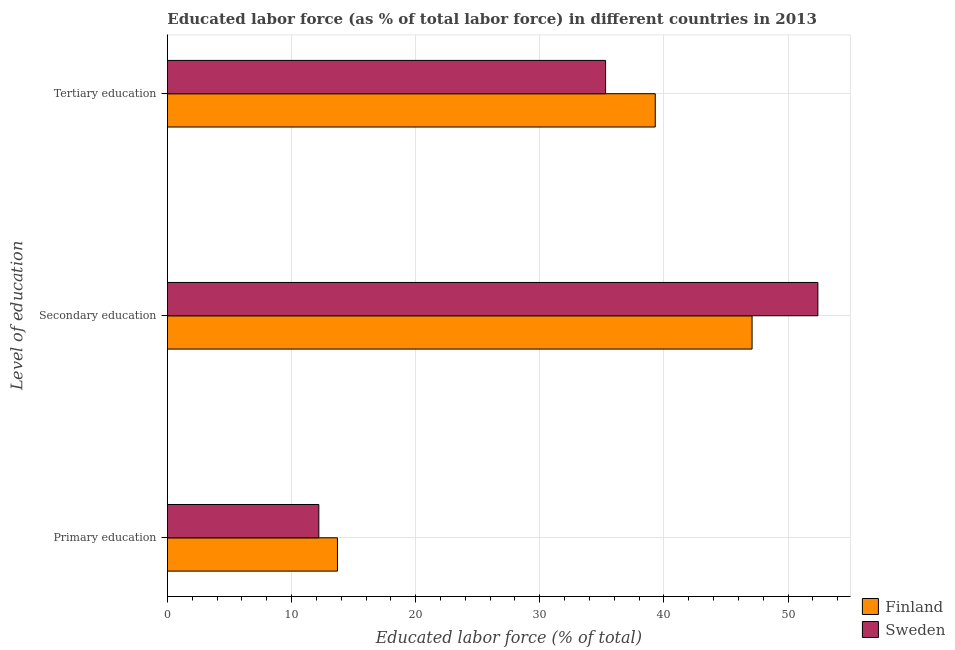How many bars are there on the 3rd tick from the top?
Provide a succinct answer. 2. What is the label of the 1st group of bars from the top?
Your answer should be compact. Tertiary education. What is the percentage of labor force who received primary education in Sweden?
Give a very brief answer. 12.2. Across all countries, what is the maximum percentage of labor force who received tertiary education?
Keep it short and to the point. 39.3. Across all countries, what is the minimum percentage of labor force who received tertiary education?
Your answer should be compact. 35.3. In which country was the percentage of labor force who received tertiary education maximum?
Offer a terse response. Finland. In which country was the percentage of labor force who received secondary education minimum?
Your response must be concise. Finland. What is the total percentage of labor force who received tertiary education in the graph?
Ensure brevity in your answer.  74.6. What is the difference between the percentage of labor force who received secondary education in Sweden and that in Finland?
Offer a terse response. 5.3. What is the difference between the percentage of labor force who received tertiary education in Sweden and the percentage of labor force who received secondary education in Finland?
Your answer should be compact. -11.8. What is the average percentage of labor force who received secondary education per country?
Make the answer very short. 49.75. What is the difference between the percentage of labor force who received tertiary education and percentage of labor force who received primary education in Sweden?
Your answer should be very brief. 23.1. In how many countries, is the percentage of labor force who received secondary education greater than 34 %?
Your answer should be very brief. 2. What is the ratio of the percentage of labor force who received primary education in Sweden to that in Finland?
Offer a very short reply. 0.89. What is the difference between the highest and the lowest percentage of labor force who received secondary education?
Provide a succinct answer. 5.3. What does the 2nd bar from the top in Primary education represents?
Give a very brief answer. Finland. How many bars are there?
Your answer should be very brief. 6. Are all the bars in the graph horizontal?
Make the answer very short. Yes. What is the difference between two consecutive major ticks on the X-axis?
Offer a very short reply. 10. Are the values on the major ticks of X-axis written in scientific E-notation?
Make the answer very short. No. Does the graph contain any zero values?
Offer a terse response. No. Does the graph contain grids?
Give a very brief answer. Yes. Where does the legend appear in the graph?
Your answer should be compact. Bottom right. How many legend labels are there?
Provide a short and direct response. 2. How are the legend labels stacked?
Ensure brevity in your answer.  Vertical. What is the title of the graph?
Your answer should be compact. Educated labor force (as % of total labor force) in different countries in 2013. Does "Trinidad and Tobago" appear as one of the legend labels in the graph?
Ensure brevity in your answer.  No. What is the label or title of the X-axis?
Provide a short and direct response. Educated labor force (% of total). What is the label or title of the Y-axis?
Provide a succinct answer. Level of education. What is the Educated labor force (% of total) in Finland in Primary education?
Your answer should be very brief. 13.7. What is the Educated labor force (% of total) in Sweden in Primary education?
Provide a short and direct response. 12.2. What is the Educated labor force (% of total) of Finland in Secondary education?
Offer a very short reply. 47.1. What is the Educated labor force (% of total) of Sweden in Secondary education?
Give a very brief answer. 52.4. What is the Educated labor force (% of total) of Finland in Tertiary education?
Give a very brief answer. 39.3. What is the Educated labor force (% of total) of Sweden in Tertiary education?
Your answer should be very brief. 35.3. Across all Level of education, what is the maximum Educated labor force (% of total) of Finland?
Offer a terse response. 47.1. Across all Level of education, what is the maximum Educated labor force (% of total) of Sweden?
Keep it short and to the point. 52.4. Across all Level of education, what is the minimum Educated labor force (% of total) in Finland?
Ensure brevity in your answer.  13.7. Across all Level of education, what is the minimum Educated labor force (% of total) of Sweden?
Offer a terse response. 12.2. What is the total Educated labor force (% of total) in Finland in the graph?
Make the answer very short. 100.1. What is the total Educated labor force (% of total) of Sweden in the graph?
Offer a very short reply. 99.9. What is the difference between the Educated labor force (% of total) in Finland in Primary education and that in Secondary education?
Provide a succinct answer. -33.4. What is the difference between the Educated labor force (% of total) in Sweden in Primary education and that in Secondary education?
Your response must be concise. -40.2. What is the difference between the Educated labor force (% of total) of Finland in Primary education and that in Tertiary education?
Offer a very short reply. -25.6. What is the difference between the Educated labor force (% of total) of Sweden in Primary education and that in Tertiary education?
Give a very brief answer. -23.1. What is the difference between the Educated labor force (% of total) of Finland in Secondary education and that in Tertiary education?
Ensure brevity in your answer.  7.8. What is the difference between the Educated labor force (% of total) of Finland in Primary education and the Educated labor force (% of total) of Sweden in Secondary education?
Your answer should be very brief. -38.7. What is the difference between the Educated labor force (% of total) of Finland in Primary education and the Educated labor force (% of total) of Sweden in Tertiary education?
Provide a short and direct response. -21.6. What is the difference between the Educated labor force (% of total) of Finland in Secondary education and the Educated labor force (% of total) of Sweden in Tertiary education?
Make the answer very short. 11.8. What is the average Educated labor force (% of total) of Finland per Level of education?
Keep it short and to the point. 33.37. What is the average Educated labor force (% of total) of Sweden per Level of education?
Your response must be concise. 33.3. What is the difference between the Educated labor force (% of total) in Finland and Educated labor force (% of total) in Sweden in Primary education?
Offer a terse response. 1.5. What is the difference between the Educated labor force (% of total) of Finland and Educated labor force (% of total) of Sweden in Tertiary education?
Provide a succinct answer. 4. What is the ratio of the Educated labor force (% of total) of Finland in Primary education to that in Secondary education?
Your answer should be compact. 0.29. What is the ratio of the Educated labor force (% of total) in Sweden in Primary education to that in Secondary education?
Provide a succinct answer. 0.23. What is the ratio of the Educated labor force (% of total) of Finland in Primary education to that in Tertiary education?
Provide a short and direct response. 0.35. What is the ratio of the Educated labor force (% of total) of Sweden in Primary education to that in Tertiary education?
Your answer should be compact. 0.35. What is the ratio of the Educated labor force (% of total) of Finland in Secondary education to that in Tertiary education?
Offer a terse response. 1.2. What is the ratio of the Educated labor force (% of total) in Sweden in Secondary education to that in Tertiary education?
Provide a succinct answer. 1.48. What is the difference between the highest and the second highest Educated labor force (% of total) in Finland?
Ensure brevity in your answer.  7.8. What is the difference between the highest and the lowest Educated labor force (% of total) in Finland?
Your answer should be compact. 33.4. What is the difference between the highest and the lowest Educated labor force (% of total) in Sweden?
Your answer should be very brief. 40.2. 